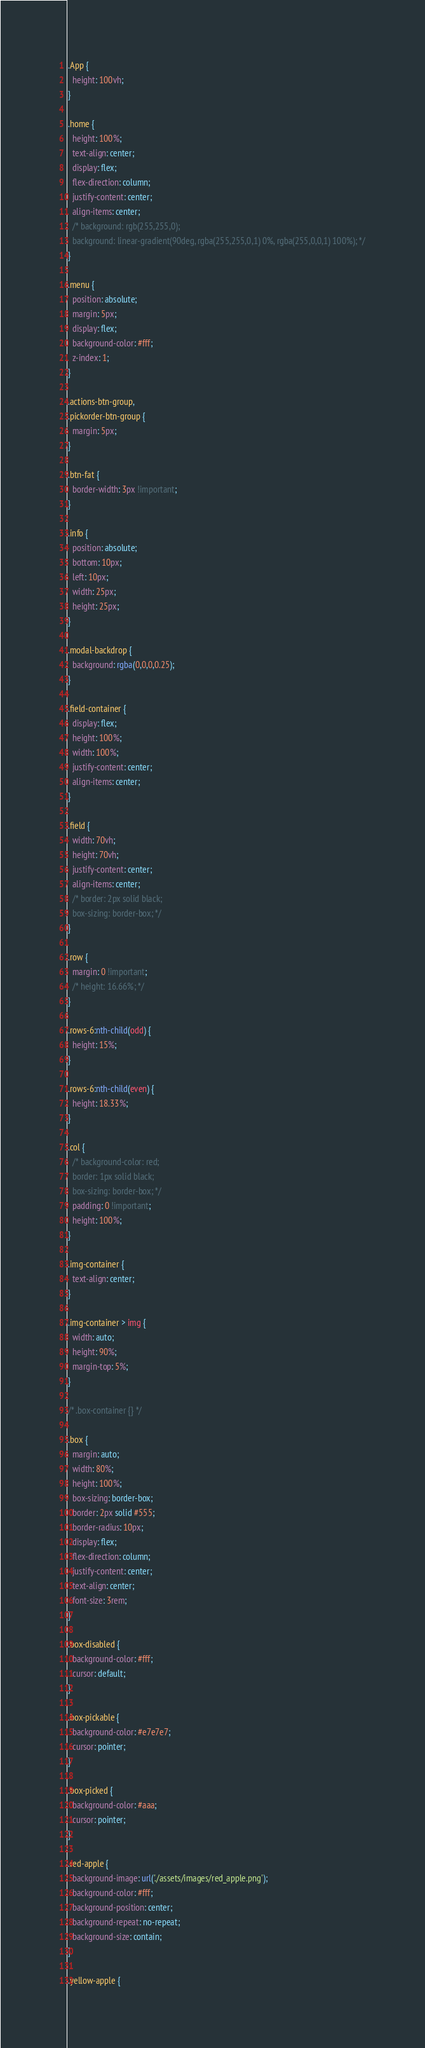<code> <loc_0><loc_0><loc_500><loc_500><_CSS_>.App {
  height: 100vh;
}

.home {
  height: 100%;
  text-align: center;
  display: flex;
  flex-direction: column;
  justify-content: center;
  align-items: center;
  /* background: rgb(255,255,0);
  background: linear-gradient(90deg, rgba(255,255,0,1) 0%, rgba(255,0,0,1) 100%); */
}

.menu {
  position: absolute;
  margin: 5px;
  display: flex;
  background-color: #fff;
  z-index: 1;
}

.actions-btn-group,
.pickorder-btn-group {
  margin: 5px;
}

.btn-fat {
  border-width: 3px !important;
}

.info {
  position: absolute;
  bottom: 10px;
  left: 10px;
  width: 25px;
  height: 25px;
}

.modal-backdrop {
  background: rgba(0,0,0,0.25);
}

.field-container {
  display: flex;
  height: 100%;
  width: 100%;
  justify-content: center;
  align-items: center;
}

.field {
  width: 70vh;
  height: 70vh;
  justify-content: center;
  align-items: center;
  /* border: 2px solid black;
  box-sizing: border-box; */
}

.row {
  margin: 0 !important;
  /* height: 16.66%; */
}

.rows-6:nth-child(odd) {
  height: 15%;
}

.rows-6:nth-child(even) {
  height: 18.33%;
}

.col {
  /* background-color: red;
  border: 1px solid black;
  box-sizing: border-box; */
  padding: 0 !important;
  height: 100%;
}

.img-container {
  text-align: center;
}

.img-container > img {
  width: auto;
  height: 90%;
  margin-top: 5%;
}

/* .box-container {} */

.box {
  margin: auto;
  width: 80%;
  height: 100%;
  box-sizing: border-box;
  border: 2px solid #555;
  border-radius: 10px;
  display: flex;
  flex-direction: column;
  justify-content: center;
  text-align: center;
  font-size: 3rem;
}

.box-disabled {
  background-color: #fff;
  cursor: default;
}

.box-pickable {
  background-color: #e7e7e7;
  cursor: pointer;
}

.box-picked {
  background-color: #aaa;
  cursor: pointer;
}

.red-apple {
  background-image: url('./assets/images/red_apple.png');
  background-color: #fff;
  background-position: center;
  background-repeat: no-repeat;
  background-size: contain;
}

.yellow-apple {</code> 